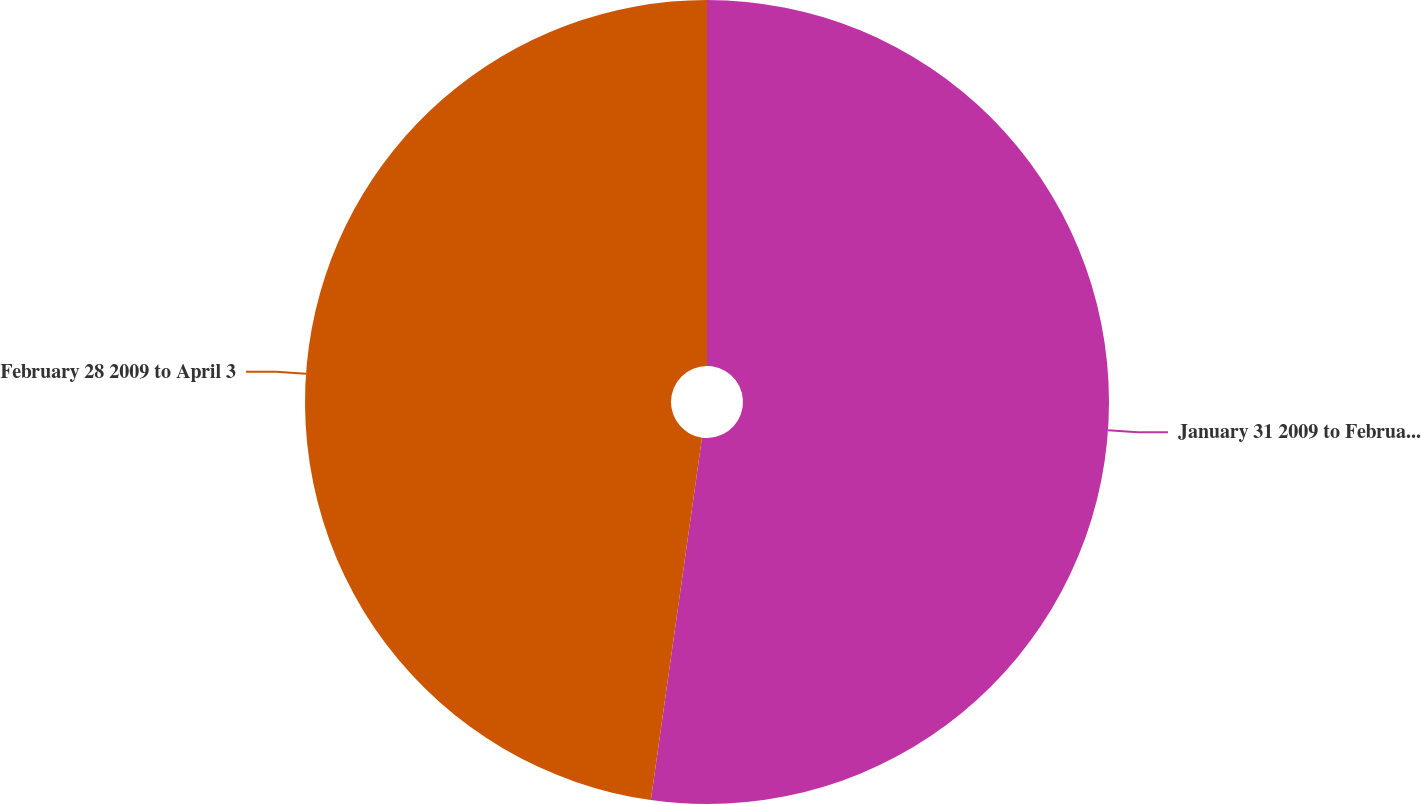Convert chart. <chart><loc_0><loc_0><loc_500><loc_500><pie_chart><fcel>January 31 2009 to February 27<fcel>February 28 2009 to April 3<nl><fcel>52.23%<fcel>47.77%<nl></chart> 